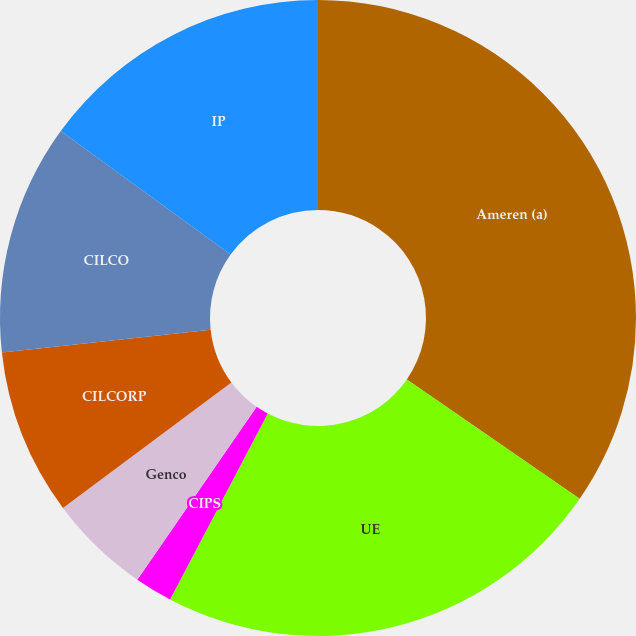<chart> <loc_0><loc_0><loc_500><loc_500><pie_chart><fcel>Ameren (a)<fcel>UE<fcel>CIPS<fcel>Genco<fcel>CILCORP<fcel>CILCO<fcel>IP<nl><fcel>34.62%<fcel>23.08%<fcel>1.92%<fcel>5.19%<fcel>8.46%<fcel>11.73%<fcel>15.0%<nl></chart> 